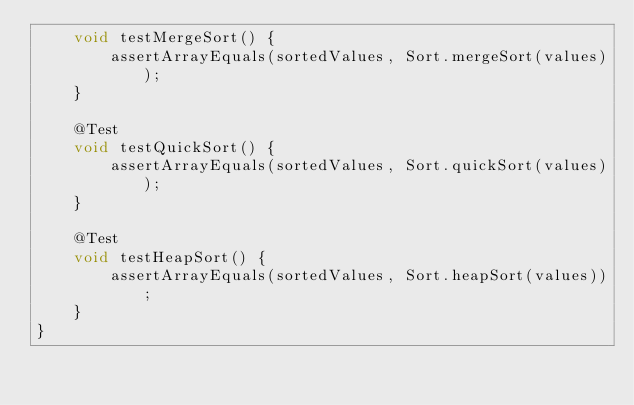Convert code to text. <code><loc_0><loc_0><loc_500><loc_500><_Java_>    void testMergeSort() {
        assertArrayEquals(sortedValues, Sort.mergeSort(values));
    }

    @Test
    void testQuickSort() {
        assertArrayEquals(sortedValues, Sort.quickSort(values));
    }

    @Test
    void testHeapSort() {
        assertArrayEquals(sortedValues, Sort.heapSort(values));
    }
}
</code> 